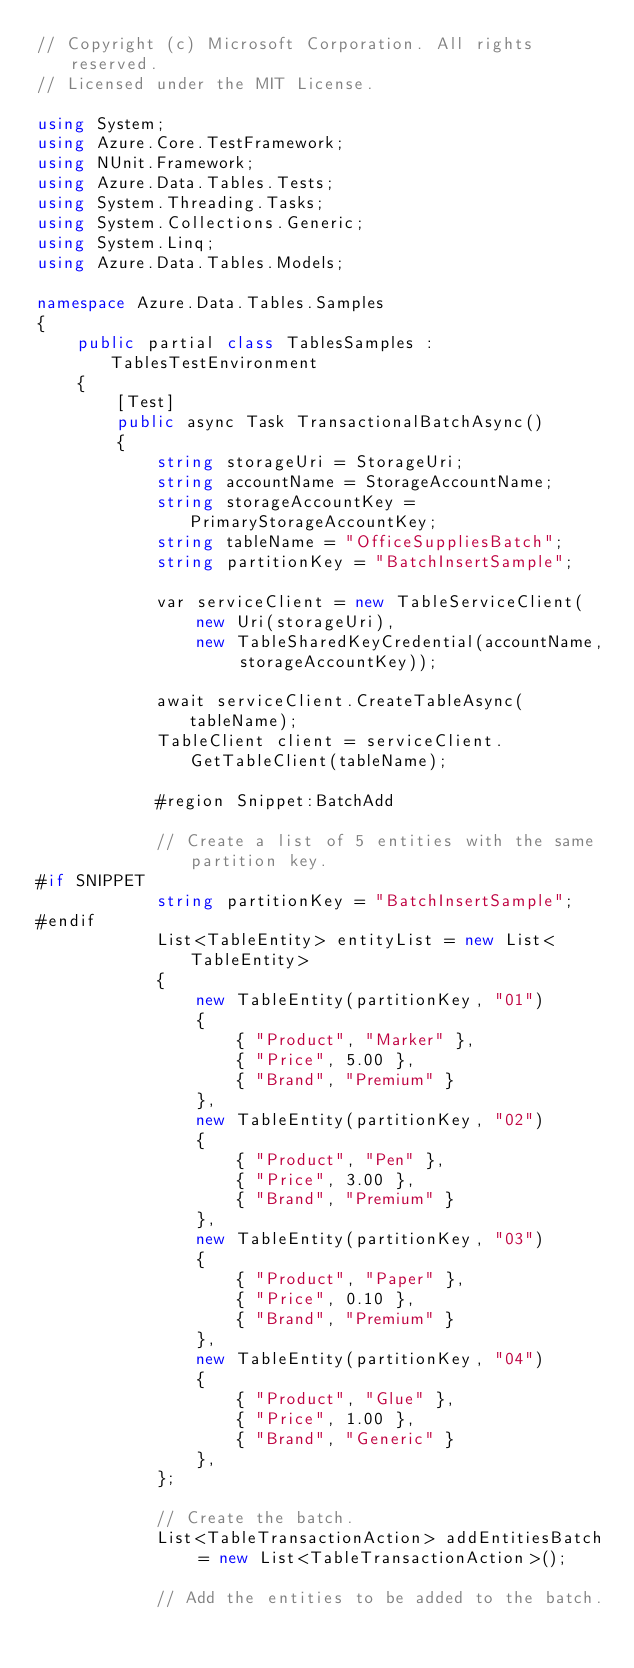Convert code to text. <code><loc_0><loc_0><loc_500><loc_500><_C#_>// Copyright (c) Microsoft Corporation. All rights reserved.
// Licensed under the MIT License.

using System;
using Azure.Core.TestFramework;
using NUnit.Framework;
using Azure.Data.Tables.Tests;
using System.Threading.Tasks;
using System.Collections.Generic;
using System.Linq;
using Azure.Data.Tables.Models;

namespace Azure.Data.Tables.Samples
{
    public partial class TablesSamples : TablesTestEnvironment
    {
        [Test]
        public async Task TransactionalBatchAsync()
        {
            string storageUri = StorageUri;
            string accountName = StorageAccountName;
            string storageAccountKey = PrimaryStorageAccountKey;
            string tableName = "OfficeSuppliesBatch";
            string partitionKey = "BatchInsertSample";

            var serviceClient = new TableServiceClient(
                new Uri(storageUri),
                new TableSharedKeyCredential(accountName, storageAccountKey));

            await serviceClient.CreateTableAsync(tableName);
            TableClient client = serviceClient.GetTableClient(tableName);

            #region Snippet:BatchAdd

            // Create a list of 5 entities with the same partition key.
#if SNIPPET
            string partitionKey = "BatchInsertSample";
#endif
            List<TableEntity> entityList = new List<TableEntity>
            {
                new TableEntity(partitionKey, "01")
                {
                    { "Product", "Marker" },
                    { "Price", 5.00 },
                    { "Brand", "Premium" }
                },
                new TableEntity(partitionKey, "02")
                {
                    { "Product", "Pen" },
                    { "Price", 3.00 },
                    { "Brand", "Premium" }
                },
                new TableEntity(partitionKey, "03")
                {
                    { "Product", "Paper" },
                    { "Price", 0.10 },
                    { "Brand", "Premium" }
                },
                new TableEntity(partitionKey, "04")
                {
                    { "Product", "Glue" },
                    { "Price", 1.00 },
                    { "Brand", "Generic" }
                },
            };

            // Create the batch.
            List<TableTransactionAction> addEntitiesBatch = new List<TableTransactionAction>();

            // Add the entities to be added to the batch.</code> 